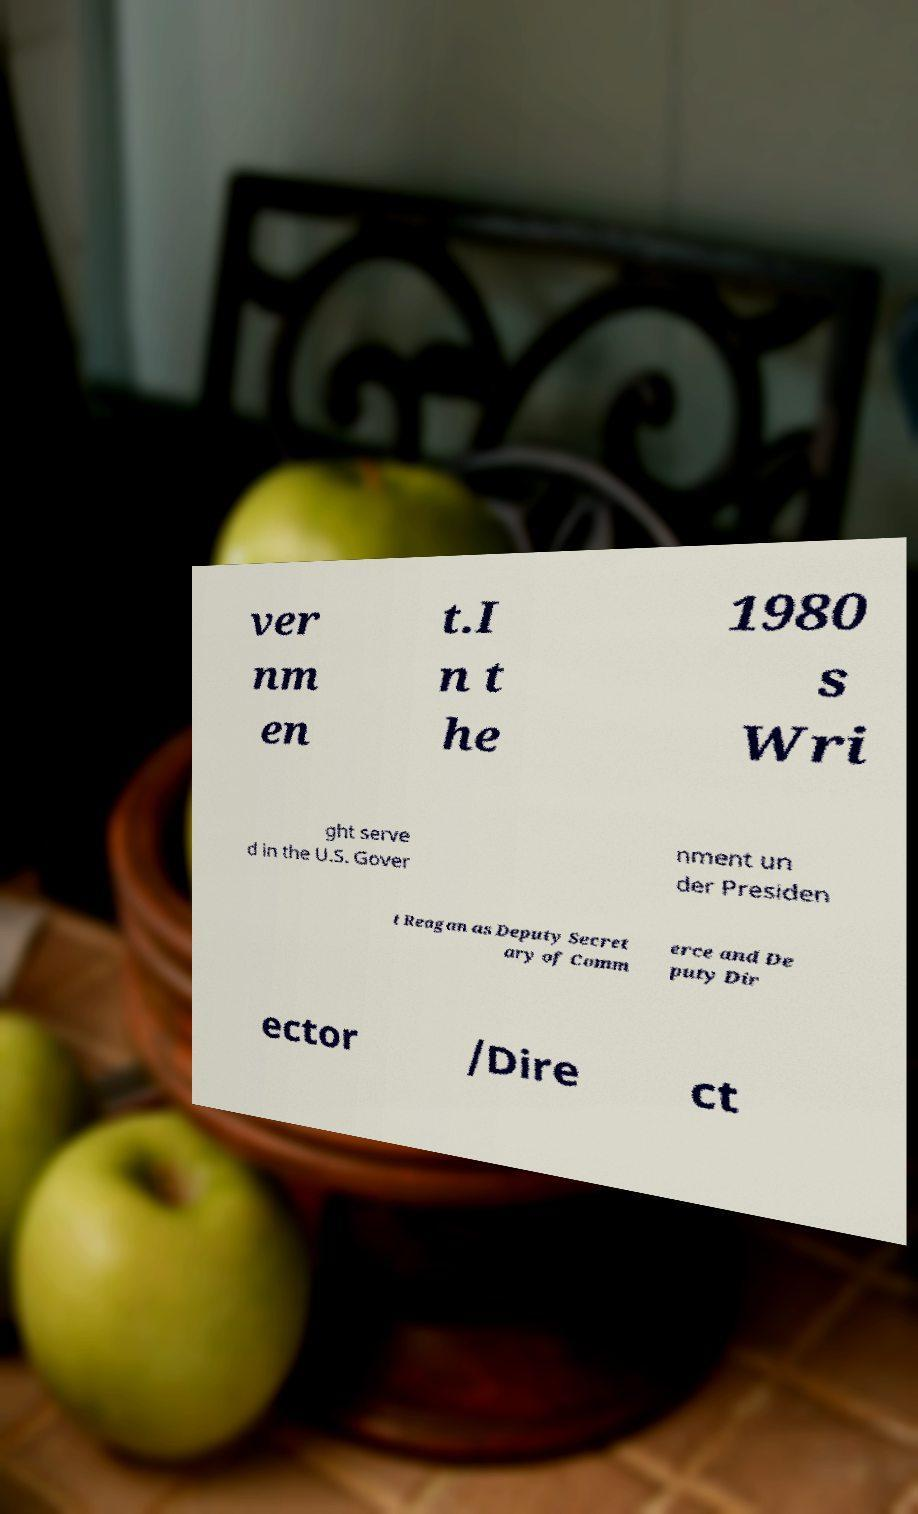There's text embedded in this image that I need extracted. Can you transcribe it verbatim? ver nm en t.I n t he 1980 s Wri ght serve d in the U.S. Gover nment un der Presiden t Reagan as Deputy Secret ary of Comm erce and De puty Dir ector /Dire ct 